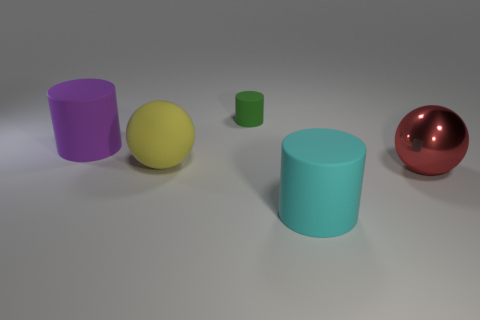Is there anything else that has the same color as the big shiny ball?
Give a very brief answer. No. What shape is the large purple thing that is made of the same material as the small cylinder?
Provide a succinct answer. Cylinder. There is a matte cylinder right of the tiny green cylinder; what is its size?
Ensure brevity in your answer.  Large. There is a tiny matte object; what shape is it?
Ensure brevity in your answer.  Cylinder. There is a matte object in front of the big shiny object; is it the same size as the thing that is right of the big cyan thing?
Offer a terse response. Yes. There is a cylinder in front of the big thing on the right side of the matte thing on the right side of the green cylinder; what size is it?
Your answer should be compact. Large. There is a rubber object that is in front of the metallic sphere that is to the right of the cylinder in front of the big red metallic thing; what shape is it?
Provide a succinct answer. Cylinder. What is the shape of the matte object left of the large yellow thing?
Make the answer very short. Cylinder. Is the large cyan thing made of the same material as the sphere that is on the left side of the green thing?
Offer a terse response. Yes. How many other objects are there of the same shape as the large red shiny object?
Your answer should be very brief. 1. 